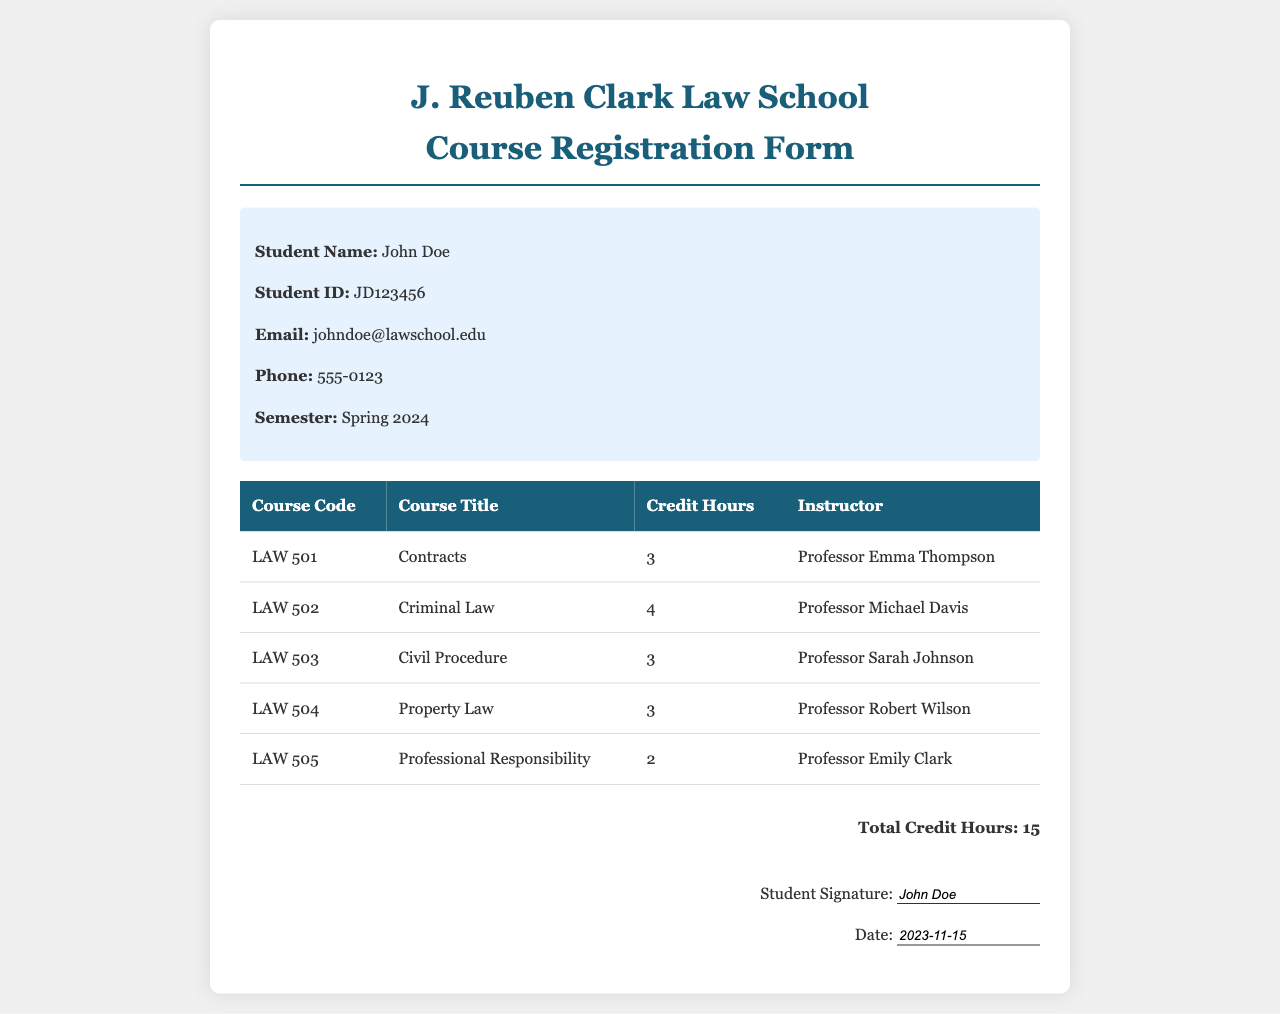What is the student's name? The student's name is provided in the student information section of the document.
Answer: John Doe Which course has the highest credit hours? By comparing the credit hours listed for each course in the table, "Criminal Law" has the most at 4 credit hours.
Answer: Criminal Law What is the total number of credit hours? The total credit hours are calculated from the sum of all courses listed in the table.
Answer: 15 Who is the instructor for Contracts? The instructor's name for Contracts is specified in the table associated with that course.
Answer: Professor Emma Thompson What date is listed for the student signature? The date provided for the student signature is shown in the signature section of the document.
Answer: 2023-11-15 How many courses are listed in total? The document lists a total of five courses in the table.
Answer: 5 What course code corresponds to Property Law? The course code is presented in the table next to the course title, allowing identification of the specific code for Property Law.
Answer: LAW 504 Who teaches Professional Responsibility? The instructor's name for Professional Responsibility can be found next to the course title in the table.
Answer: Professor Emily Clark 